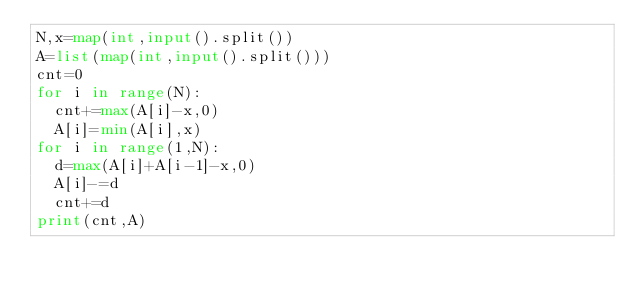Convert code to text. <code><loc_0><loc_0><loc_500><loc_500><_Python_>N,x=map(int,input().split())
A=list(map(int,input().split()))
cnt=0
for i in range(N):
  cnt+=max(A[i]-x,0)
  A[i]=min(A[i],x)
for i in range(1,N):
  d=max(A[i]+A[i-1]-x,0)
  A[i]-=d
  cnt+=d
print(cnt,A)</code> 